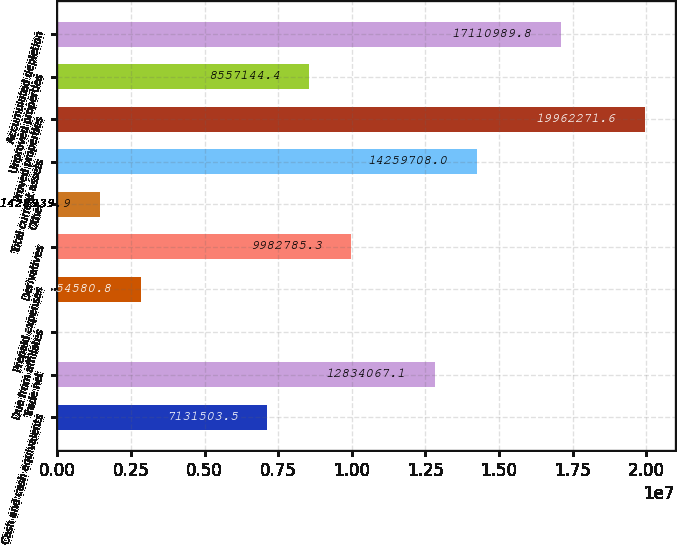<chart> <loc_0><loc_0><loc_500><loc_500><bar_chart><fcel>Cash and cash equivalents<fcel>Trade net<fcel>Due from affiliates<fcel>Prepaid expenses<fcel>Derivatives<fcel>Other<fcel>Total current assets<fcel>Proved properties<fcel>Unproved properties<fcel>Accumulated depletion<nl><fcel>7.1315e+06<fcel>1.28341e+07<fcel>3299<fcel>2.85458e+06<fcel>9.98279e+06<fcel>1.42894e+06<fcel>1.42597e+07<fcel>1.99623e+07<fcel>8.55714e+06<fcel>1.7111e+07<nl></chart> 